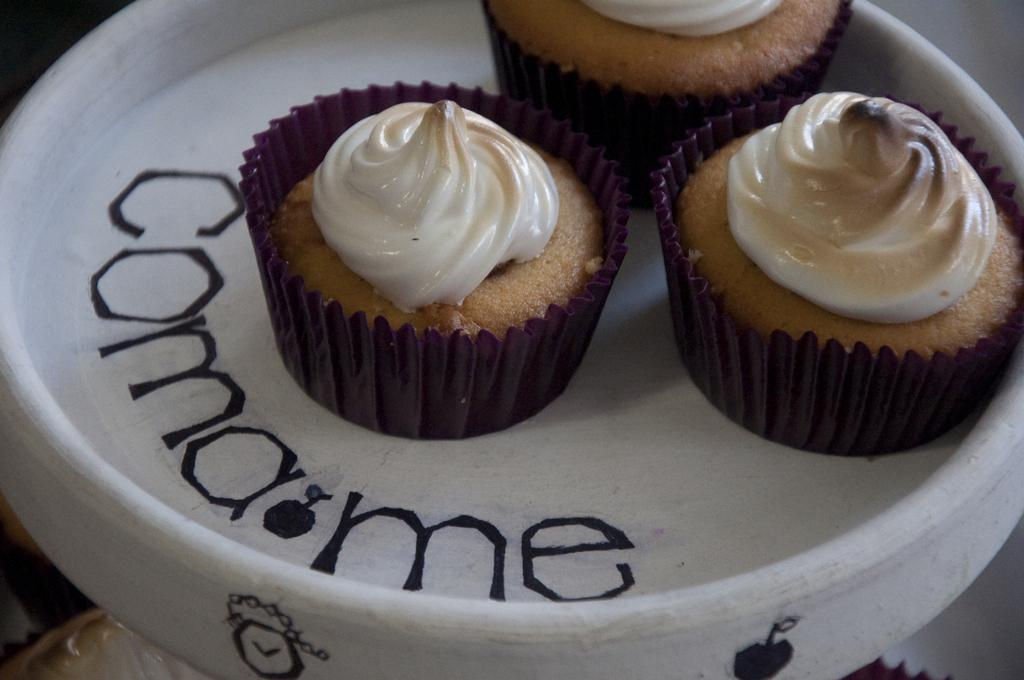What type of food is visible in the image? There are cupcakes in the image. How are the cupcakes arranged or contained in the image? The cupcakes are in a bowl. What type of corn can be seen growing in the image? There is no corn present in the image; it features cupcakes in a bowl. Can you provide a receipt for the cupcakes in the image? There is no receipt present in the image, as it only shows cupcakes in a bowl. 